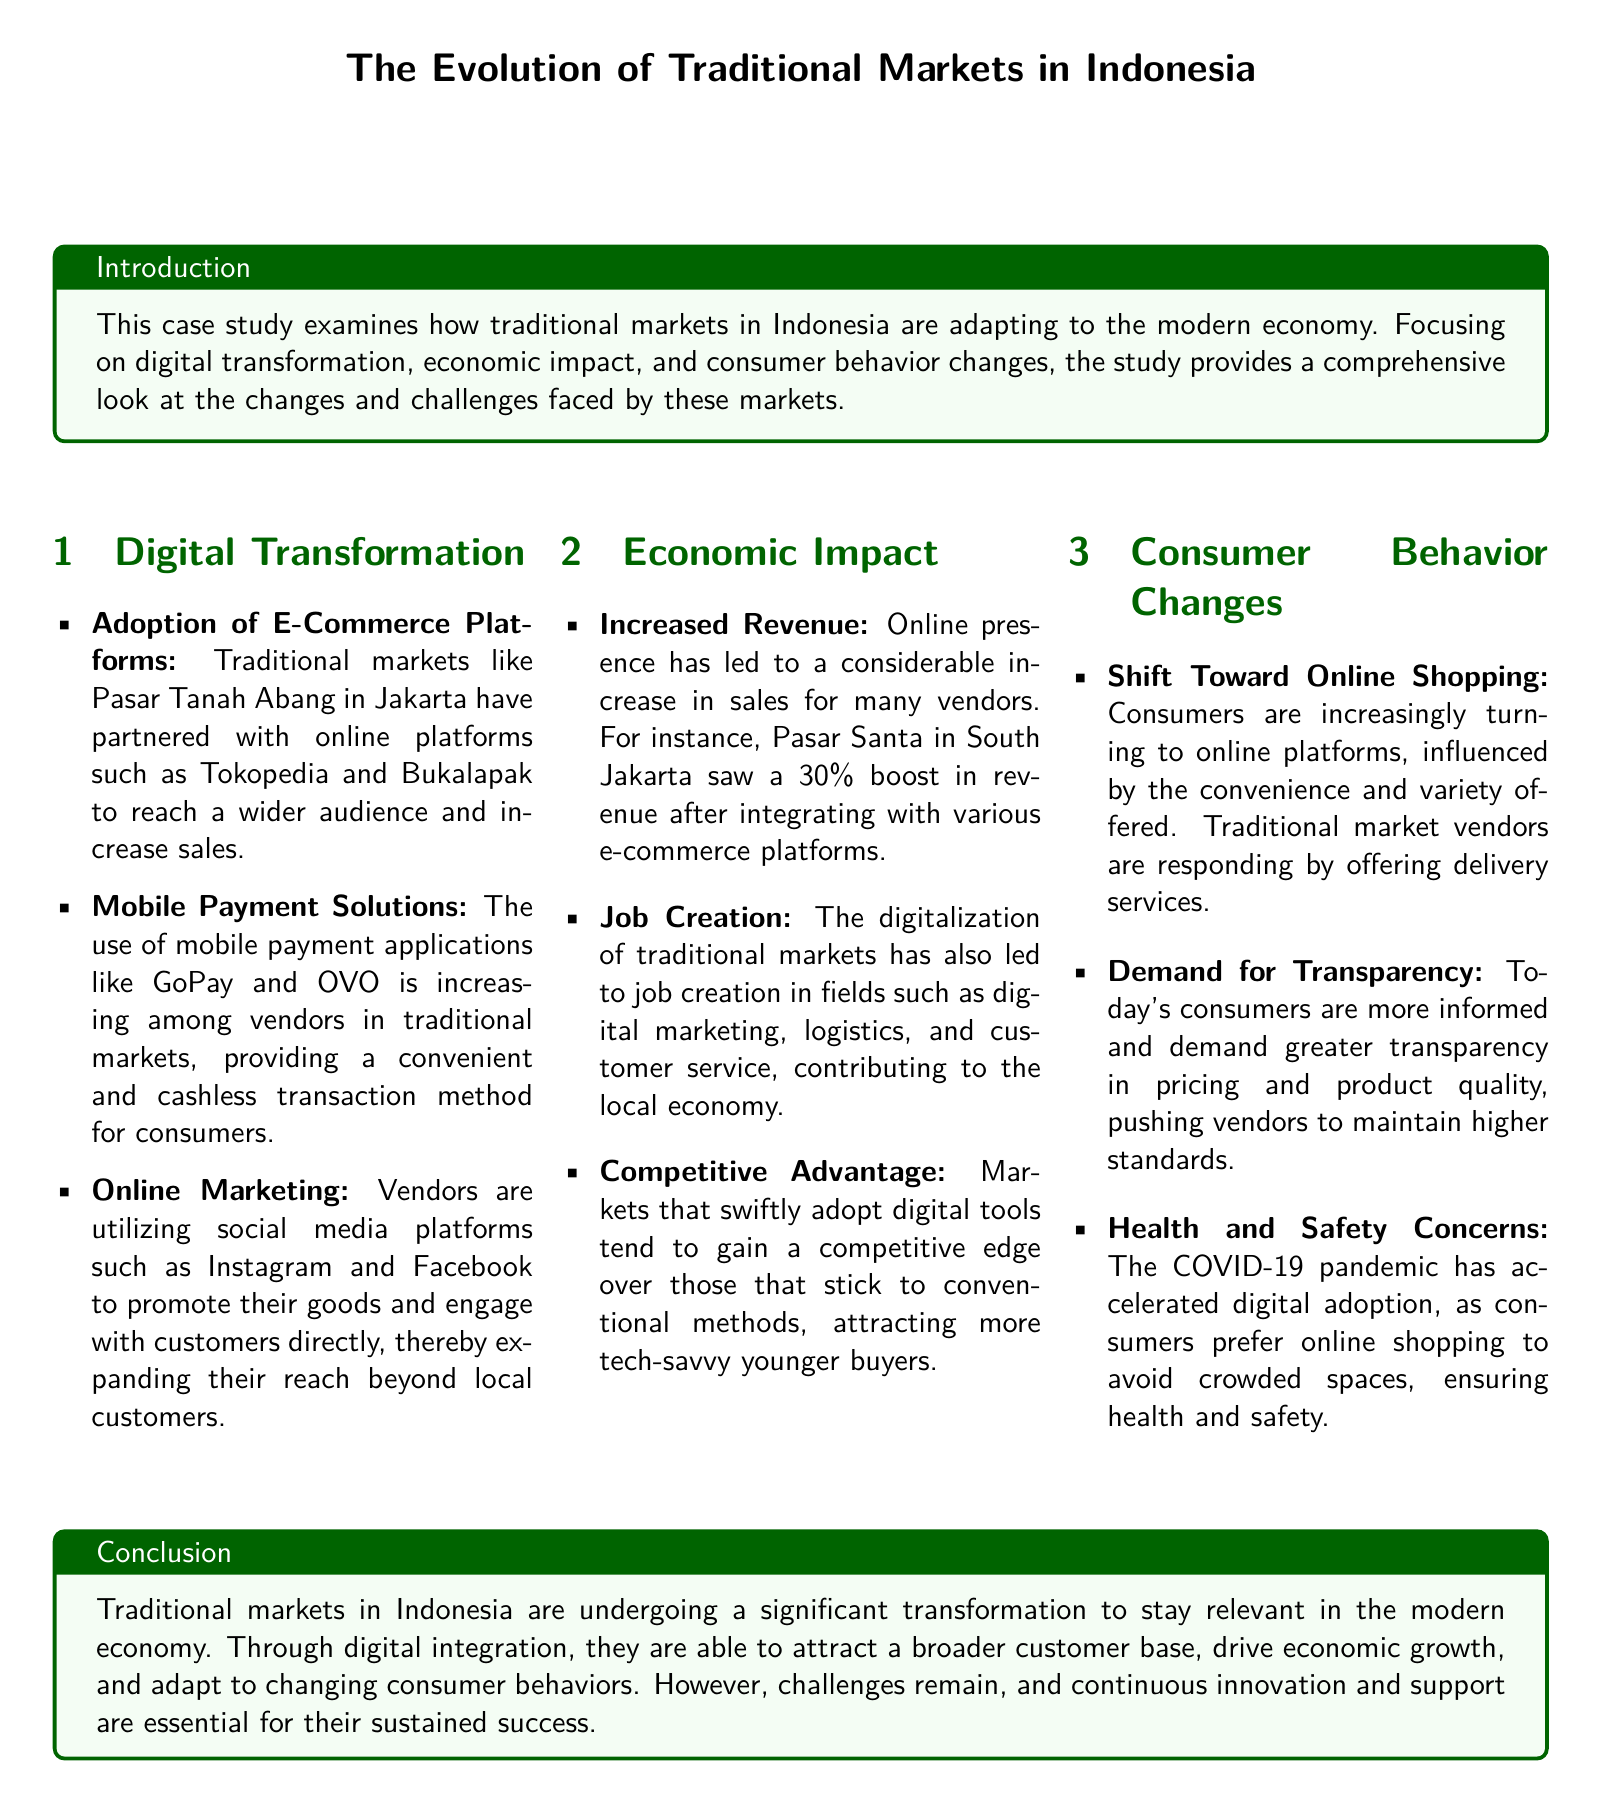what traditional market in Jakarta partnered with online platforms? The document mentions Pasar Tanah Abang as a traditional market in Jakarta that partnered with online platforms like Tokopedia and Bukalapak.
Answer: Pasar Tanah Abang what payment solutions are increasing among traditional market vendors? The text indicates that mobile payment applications like GoPay and OVO are increasingly used by vendors.
Answer: Mobile payment applications by what percentage did Pasar Santa see a revenue boost after digital integration? The document states that Pasar Santa in South Jakarta saw a 30% boost in revenue after integrating with various e-commerce platforms.
Answer: 30% what economic benefit does digitalization bring to traditional markets? The document notes that job creation in fields such as digital marketing, logistics, and customer service is an economic benefit of digitalization.
Answer: Job creation what consumer behavior trend has accelerated due to the COVID-19 pandemic? The text explains that consumers are preferring online shopping to avoid crowded spaces, a trend accelerated by the COVID-19 pandemic.
Answer: Online shopping what type of marketing are traditional market vendors utilizing? The document mentions that vendors are utilizing social media platforms such as Instagram and Facebook for marketing.
Answer: Online marketing what is a key demand from today's consumers regarding product standards? Today's consumers are demanding greater transparency in pricing and product quality, as stated in the document.
Answer: Transparency what is necessary for the sustained success of traditional markets? Continuous innovation and support are essential for the sustained success of traditional markets, according to the conclusion of the document.
Answer: Continuous innovation and support 